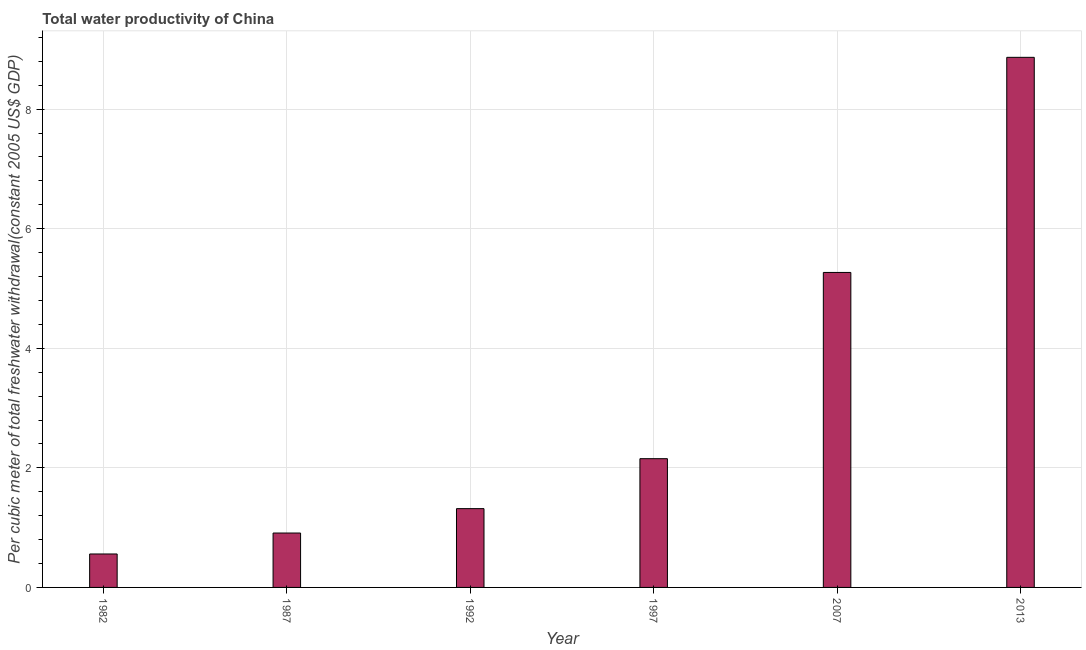Does the graph contain any zero values?
Offer a very short reply. No. What is the title of the graph?
Your response must be concise. Total water productivity of China. What is the label or title of the Y-axis?
Your answer should be very brief. Per cubic meter of total freshwater withdrawal(constant 2005 US$ GDP). What is the total water productivity in 1997?
Your answer should be compact. 2.15. Across all years, what is the maximum total water productivity?
Provide a succinct answer. 8.87. Across all years, what is the minimum total water productivity?
Your answer should be compact. 0.56. In which year was the total water productivity maximum?
Your response must be concise. 2013. In which year was the total water productivity minimum?
Offer a terse response. 1982. What is the sum of the total water productivity?
Offer a terse response. 19.08. What is the difference between the total water productivity in 1992 and 2013?
Provide a succinct answer. -7.55. What is the average total water productivity per year?
Offer a very short reply. 3.18. What is the median total water productivity?
Keep it short and to the point. 1.74. What is the ratio of the total water productivity in 1982 to that in 2013?
Give a very brief answer. 0.06. Is the difference between the total water productivity in 2007 and 2013 greater than the difference between any two years?
Your answer should be very brief. No. What is the difference between the highest and the second highest total water productivity?
Keep it short and to the point. 3.6. What is the difference between the highest and the lowest total water productivity?
Offer a terse response. 8.31. How many bars are there?
Provide a short and direct response. 6. What is the difference between two consecutive major ticks on the Y-axis?
Offer a terse response. 2. Are the values on the major ticks of Y-axis written in scientific E-notation?
Your response must be concise. No. What is the Per cubic meter of total freshwater withdrawal(constant 2005 US$ GDP) in 1982?
Offer a terse response. 0.56. What is the Per cubic meter of total freshwater withdrawal(constant 2005 US$ GDP) in 1987?
Offer a very short reply. 0.91. What is the Per cubic meter of total freshwater withdrawal(constant 2005 US$ GDP) in 1992?
Ensure brevity in your answer.  1.32. What is the Per cubic meter of total freshwater withdrawal(constant 2005 US$ GDP) of 1997?
Your answer should be compact. 2.15. What is the Per cubic meter of total freshwater withdrawal(constant 2005 US$ GDP) of 2007?
Ensure brevity in your answer.  5.27. What is the Per cubic meter of total freshwater withdrawal(constant 2005 US$ GDP) of 2013?
Keep it short and to the point. 8.87. What is the difference between the Per cubic meter of total freshwater withdrawal(constant 2005 US$ GDP) in 1982 and 1987?
Ensure brevity in your answer.  -0.35. What is the difference between the Per cubic meter of total freshwater withdrawal(constant 2005 US$ GDP) in 1982 and 1992?
Keep it short and to the point. -0.76. What is the difference between the Per cubic meter of total freshwater withdrawal(constant 2005 US$ GDP) in 1982 and 1997?
Offer a terse response. -1.59. What is the difference between the Per cubic meter of total freshwater withdrawal(constant 2005 US$ GDP) in 1982 and 2007?
Keep it short and to the point. -4.71. What is the difference between the Per cubic meter of total freshwater withdrawal(constant 2005 US$ GDP) in 1982 and 2013?
Offer a very short reply. -8.31. What is the difference between the Per cubic meter of total freshwater withdrawal(constant 2005 US$ GDP) in 1987 and 1992?
Your answer should be very brief. -0.41. What is the difference between the Per cubic meter of total freshwater withdrawal(constant 2005 US$ GDP) in 1987 and 1997?
Keep it short and to the point. -1.24. What is the difference between the Per cubic meter of total freshwater withdrawal(constant 2005 US$ GDP) in 1987 and 2007?
Offer a terse response. -4.36. What is the difference between the Per cubic meter of total freshwater withdrawal(constant 2005 US$ GDP) in 1987 and 2013?
Your response must be concise. -7.96. What is the difference between the Per cubic meter of total freshwater withdrawal(constant 2005 US$ GDP) in 1992 and 1997?
Provide a short and direct response. -0.84. What is the difference between the Per cubic meter of total freshwater withdrawal(constant 2005 US$ GDP) in 1992 and 2007?
Keep it short and to the point. -3.95. What is the difference between the Per cubic meter of total freshwater withdrawal(constant 2005 US$ GDP) in 1992 and 2013?
Offer a terse response. -7.55. What is the difference between the Per cubic meter of total freshwater withdrawal(constant 2005 US$ GDP) in 1997 and 2007?
Offer a terse response. -3.12. What is the difference between the Per cubic meter of total freshwater withdrawal(constant 2005 US$ GDP) in 1997 and 2013?
Keep it short and to the point. -6.71. What is the difference between the Per cubic meter of total freshwater withdrawal(constant 2005 US$ GDP) in 2007 and 2013?
Your answer should be compact. -3.6. What is the ratio of the Per cubic meter of total freshwater withdrawal(constant 2005 US$ GDP) in 1982 to that in 1987?
Your response must be concise. 0.61. What is the ratio of the Per cubic meter of total freshwater withdrawal(constant 2005 US$ GDP) in 1982 to that in 1992?
Keep it short and to the point. 0.42. What is the ratio of the Per cubic meter of total freshwater withdrawal(constant 2005 US$ GDP) in 1982 to that in 1997?
Make the answer very short. 0.26. What is the ratio of the Per cubic meter of total freshwater withdrawal(constant 2005 US$ GDP) in 1982 to that in 2007?
Your response must be concise. 0.11. What is the ratio of the Per cubic meter of total freshwater withdrawal(constant 2005 US$ GDP) in 1982 to that in 2013?
Your answer should be very brief. 0.06. What is the ratio of the Per cubic meter of total freshwater withdrawal(constant 2005 US$ GDP) in 1987 to that in 1992?
Your response must be concise. 0.69. What is the ratio of the Per cubic meter of total freshwater withdrawal(constant 2005 US$ GDP) in 1987 to that in 1997?
Give a very brief answer. 0.42. What is the ratio of the Per cubic meter of total freshwater withdrawal(constant 2005 US$ GDP) in 1987 to that in 2007?
Provide a succinct answer. 0.17. What is the ratio of the Per cubic meter of total freshwater withdrawal(constant 2005 US$ GDP) in 1987 to that in 2013?
Offer a very short reply. 0.1. What is the ratio of the Per cubic meter of total freshwater withdrawal(constant 2005 US$ GDP) in 1992 to that in 1997?
Offer a terse response. 0.61. What is the ratio of the Per cubic meter of total freshwater withdrawal(constant 2005 US$ GDP) in 1992 to that in 2013?
Offer a very short reply. 0.15. What is the ratio of the Per cubic meter of total freshwater withdrawal(constant 2005 US$ GDP) in 1997 to that in 2007?
Make the answer very short. 0.41. What is the ratio of the Per cubic meter of total freshwater withdrawal(constant 2005 US$ GDP) in 1997 to that in 2013?
Your response must be concise. 0.24. What is the ratio of the Per cubic meter of total freshwater withdrawal(constant 2005 US$ GDP) in 2007 to that in 2013?
Your answer should be compact. 0.59. 